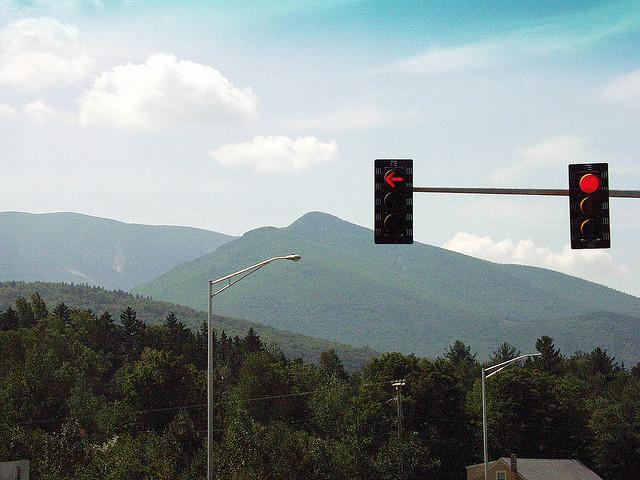How many traffic lights can be seen?
Give a very brief answer. 2. 